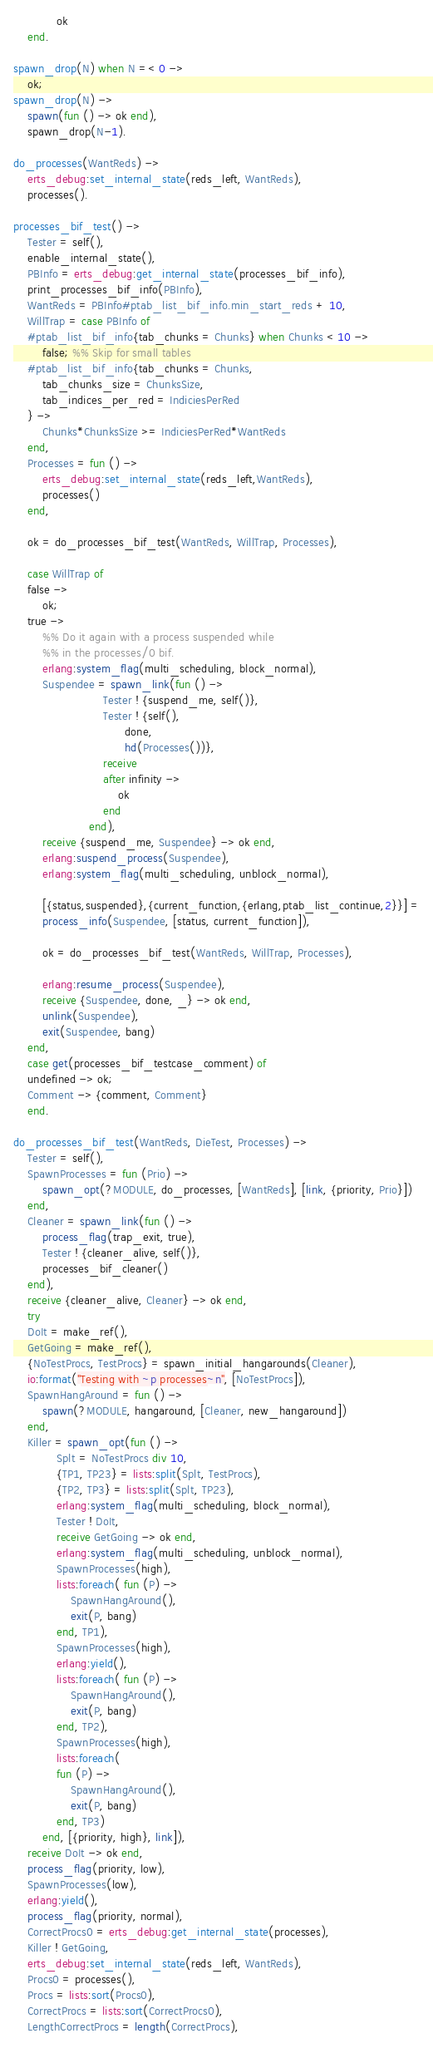Convert code to text. <code><loc_0><loc_0><loc_500><loc_500><_Erlang_>            ok
    end.

spawn_drop(N) when N =< 0 ->
    ok;
spawn_drop(N) ->
    spawn(fun () -> ok end),
    spawn_drop(N-1).

do_processes(WantReds) ->
    erts_debug:set_internal_state(reds_left, WantReds),
    processes().

processes_bif_test() ->
    Tester = self(),
    enable_internal_state(),
    PBInfo = erts_debug:get_internal_state(processes_bif_info),
    print_processes_bif_info(PBInfo),
    WantReds = PBInfo#ptab_list_bif_info.min_start_reds + 10,
    WillTrap = case PBInfo of
	#ptab_list_bif_info{tab_chunks = Chunks} when Chunks < 10 ->
	    false; %% Skip for small tables
	#ptab_list_bif_info{tab_chunks = Chunks,
	    tab_chunks_size = ChunksSize,
	    tab_indices_per_red = IndiciesPerRed
	} ->
	    Chunks*ChunksSize >= IndiciesPerRed*WantReds
    end,
    Processes = fun () ->
	    erts_debug:set_internal_state(reds_left,WantReds),
	    processes()
    end,

    ok = do_processes_bif_test(WantReds, WillTrap, Processes),

    case WillTrap of
	false ->
	    ok;
	true ->
	    %% Do it again with a process suspended while
	    %% in the processes/0 bif.
	    erlang:system_flag(multi_scheduling, block_normal),
	    Suspendee = spawn_link(fun () ->
						 Tester ! {suspend_me, self()},
						 Tester ! {self(),
							   done,
							   hd(Processes())},
						 receive
						 after infinity ->
							 ok
						 end
					 end),
	    receive {suspend_me, Suspendee} -> ok end,
	    erlang:suspend_process(Suspendee),
	    erlang:system_flag(multi_scheduling, unblock_normal),
	    
	    [{status,suspended},{current_function,{erlang,ptab_list_continue,2}}] =
		process_info(Suspendee, [status, current_function]),

	    ok = do_processes_bif_test(WantReds, WillTrap, Processes),
	    
	    erlang:resume_process(Suspendee),
	    receive {Suspendee, done, _} -> ok end,
	    unlink(Suspendee),
	    exit(Suspendee, bang)
    end,
    case get(processes_bif_testcase_comment) of
	undefined -> ok;
	Comment -> {comment, Comment}
    end.
    
do_processes_bif_test(WantReds, DieTest, Processes) ->
    Tester = self(),
    SpawnProcesses = fun (Prio) ->
	    spawn_opt(?MODULE, do_processes, [WantReds], [link, {priority, Prio}])
    end,
    Cleaner = spawn_link(fun () ->
		process_flag(trap_exit, true),
		Tester ! {cleaner_alive, self()},
		processes_bif_cleaner()
	end),
    receive {cleaner_alive, Cleaner} -> ok end,
    try
	DoIt = make_ref(),
	GetGoing = make_ref(),
	{NoTestProcs, TestProcs} = spawn_initial_hangarounds(Cleaner),
	io:format("Testing with ~p processes~n", [NoTestProcs]),
	SpawnHangAround = fun () ->
		spawn(?MODULE, hangaround, [Cleaner, new_hangaround])
	end,
	Killer = spawn_opt(fun () ->
		    Splt = NoTestProcs div 10,
		    {TP1, TP23} = lists:split(Splt, TestProcs),
		    {TP2, TP3} = lists:split(Splt, TP23),
		    erlang:system_flag(multi_scheduling, block_normal),
		    Tester ! DoIt,
		    receive GetGoing -> ok end,
		    erlang:system_flag(multi_scheduling, unblock_normal),
		    SpawnProcesses(high),
		    lists:foreach( fun (P) ->
				SpawnHangAround(),
				exit(P, bang)
			end, TP1),
		    SpawnProcesses(high),
		    erlang:yield(),
		    lists:foreach( fun (P) ->
				SpawnHangAround(),
				exit(P, bang)
			end, TP2),
		    SpawnProcesses(high),
		    lists:foreach(
			fun (P) ->
				SpawnHangAround(),
				exit(P, bang)
			end, TP3)
	    end, [{priority, high}, link]),
	receive DoIt -> ok end,
	process_flag(priority, low),
	SpawnProcesses(low),
	erlang:yield(),
	process_flag(priority, normal),
	CorrectProcs0 = erts_debug:get_internal_state(processes),
	Killer ! GetGoing,
	erts_debug:set_internal_state(reds_left, WantReds),
	Procs0 = processes(),
	Procs = lists:sort(Procs0),
	CorrectProcs = lists:sort(CorrectProcs0),
	LengthCorrectProcs = length(CorrectProcs),</code> 